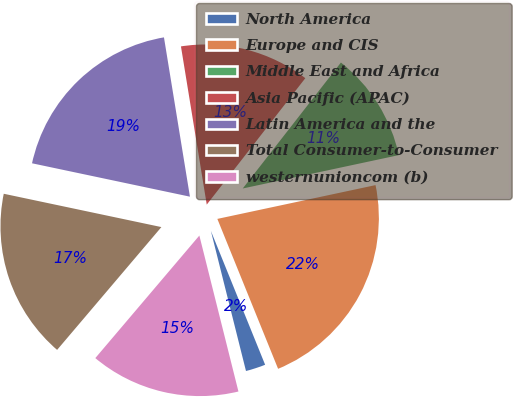<chart> <loc_0><loc_0><loc_500><loc_500><pie_chart><fcel>North America<fcel>Europe and CIS<fcel>Middle East and Africa<fcel>Asia Pacific (APAC)<fcel>Latin America and the<fcel>Total Consumer-to-Consumer<fcel>westernunioncom (b)<nl><fcel>2.22%<fcel>22.22%<fcel>11.11%<fcel>13.11%<fcel>19.11%<fcel>17.11%<fcel>15.11%<nl></chart> 